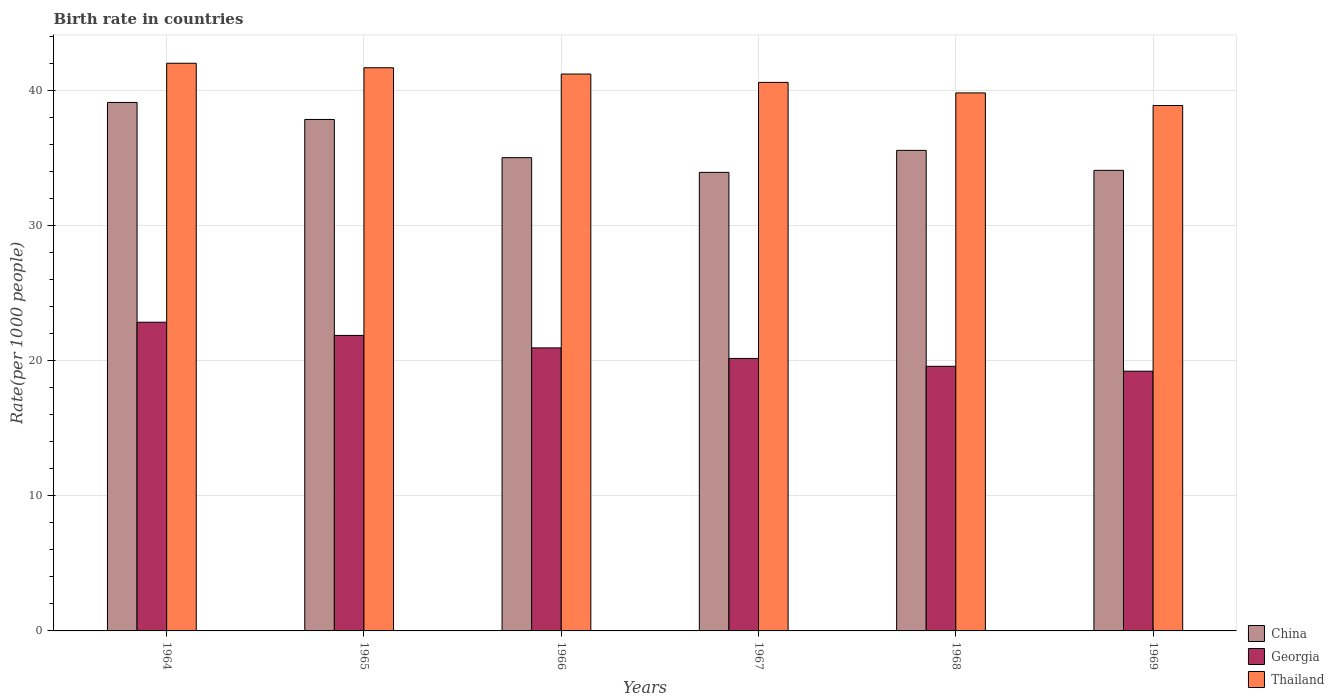How many groups of bars are there?
Your response must be concise. 6. Are the number of bars per tick equal to the number of legend labels?
Give a very brief answer. Yes. Are the number of bars on each tick of the X-axis equal?
Keep it short and to the point. Yes. How many bars are there on the 1st tick from the right?
Ensure brevity in your answer.  3. What is the label of the 2nd group of bars from the left?
Your answer should be compact. 1965. What is the birth rate in China in 1968?
Your answer should be very brief. 35.59. Across all years, what is the maximum birth rate in Georgia?
Ensure brevity in your answer.  22.86. Across all years, what is the minimum birth rate in Thailand?
Offer a terse response. 38.91. In which year was the birth rate in Thailand maximum?
Your answer should be very brief. 1964. In which year was the birth rate in China minimum?
Your answer should be very brief. 1967. What is the total birth rate in Georgia in the graph?
Provide a short and direct response. 124.72. What is the difference between the birth rate in Georgia in 1964 and that in 1968?
Offer a terse response. 3.26. What is the difference between the birth rate in Thailand in 1966 and the birth rate in Georgia in 1967?
Offer a very short reply. 21.06. What is the average birth rate in Georgia per year?
Offer a terse response. 20.79. In the year 1969, what is the difference between the birth rate in Thailand and birth rate in Georgia?
Your answer should be very brief. 19.68. What is the ratio of the birth rate in Thailand in 1965 to that in 1966?
Provide a short and direct response. 1.01. Is the birth rate in Thailand in 1965 less than that in 1969?
Offer a terse response. No. Is the difference between the birth rate in Thailand in 1966 and 1968 greater than the difference between the birth rate in Georgia in 1966 and 1968?
Your answer should be compact. Yes. What is the difference between the highest and the second highest birth rate in Thailand?
Ensure brevity in your answer.  0.33. What is the difference between the highest and the lowest birth rate in Thailand?
Offer a very short reply. 3.13. In how many years, is the birth rate in China greater than the average birth rate in China taken over all years?
Ensure brevity in your answer.  2. What does the 3rd bar from the left in 1964 represents?
Your response must be concise. Thailand. What does the 3rd bar from the right in 1967 represents?
Give a very brief answer. China. Is it the case that in every year, the sum of the birth rate in China and birth rate in Thailand is greater than the birth rate in Georgia?
Provide a succinct answer. Yes. How many bars are there?
Keep it short and to the point. 18. Are all the bars in the graph horizontal?
Offer a very short reply. No. How many years are there in the graph?
Ensure brevity in your answer.  6. What is the difference between two consecutive major ticks on the Y-axis?
Make the answer very short. 10. Are the values on the major ticks of Y-axis written in scientific E-notation?
Make the answer very short. No. Does the graph contain grids?
Keep it short and to the point. Yes. How many legend labels are there?
Ensure brevity in your answer.  3. What is the title of the graph?
Provide a succinct answer. Birth rate in countries. What is the label or title of the Y-axis?
Provide a succinct answer. Rate(per 1000 people). What is the Rate(per 1000 people) in China in 1964?
Your answer should be very brief. 39.14. What is the Rate(per 1000 people) in Georgia in 1964?
Provide a succinct answer. 22.86. What is the Rate(per 1000 people) in Thailand in 1964?
Your answer should be compact. 42.04. What is the Rate(per 1000 people) in China in 1965?
Keep it short and to the point. 37.88. What is the Rate(per 1000 people) in Georgia in 1965?
Your answer should be very brief. 21.89. What is the Rate(per 1000 people) of Thailand in 1965?
Your answer should be very brief. 41.71. What is the Rate(per 1000 people) of China in 1966?
Your response must be concise. 35.05. What is the Rate(per 1000 people) of Georgia in 1966?
Ensure brevity in your answer.  20.96. What is the Rate(per 1000 people) of Thailand in 1966?
Offer a very short reply. 41.24. What is the Rate(per 1000 people) in China in 1967?
Provide a succinct answer. 33.96. What is the Rate(per 1000 people) in Georgia in 1967?
Give a very brief answer. 20.18. What is the Rate(per 1000 people) in Thailand in 1967?
Offer a very short reply. 40.62. What is the Rate(per 1000 people) in China in 1968?
Ensure brevity in your answer.  35.59. What is the Rate(per 1000 people) of Georgia in 1968?
Offer a very short reply. 19.6. What is the Rate(per 1000 people) in Thailand in 1968?
Your answer should be compact. 39.85. What is the Rate(per 1000 people) of China in 1969?
Your answer should be very brief. 34.11. What is the Rate(per 1000 people) in Georgia in 1969?
Your answer should be compact. 19.24. What is the Rate(per 1000 people) in Thailand in 1969?
Your answer should be very brief. 38.91. Across all years, what is the maximum Rate(per 1000 people) of China?
Provide a succinct answer. 39.14. Across all years, what is the maximum Rate(per 1000 people) of Georgia?
Give a very brief answer. 22.86. Across all years, what is the maximum Rate(per 1000 people) of Thailand?
Your response must be concise. 42.04. Across all years, what is the minimum Rate(per 1000 people) of China?
Keep it short and to the point. 33.96. Across all years, what is the minimum Rate(per 1000 people) of Georgia?
Offer a terse response. 19.24. Across all years, what is the minimum Rate(per 1000 people) of Thailand?
Give a very brief answer. 38.91. What is the total Rate(per 1000 people) in China in the graph?
Ensure brevity in your answer.  215.73. What is the total Rate(per 1000 people) of Georgia in the graph?
Offer a very short reply. 124.72. What is the total Rate(per 1000 people) in Thailand in the graph?
Provide a short and direct response. 244.38. What is the difference between the Rate(per 1000 people) of China in 1964 and that in 1965?
Provide a short and direct response. 1.26. What is the difference between the Rate(per 1000 people) in Thailand in 1964 and that in 1965?
Your response must be concise. 0.33. What is the difference between the Rate(per 1000 people) of China in 1964 and that in 1966?
Offer a very short reply. 4.09. What is the difference between the Rate(per 1000 people) of Thailand in 1964 and that in 1966?
Provide a succinct answer. 0.8. What is the difference between the Rate(per 1000 people) in China in 1964 and that in 1967?
Ensure brevity in your answer.  5.18. What is the difference between the Rate(per 1000 people) in Georgia in 1964 and that in 1967?
Give a very brief answer. 2.68. What is the difference between the Rate(per 1000 people) in Thailand in 1964 and that in 1967?
Offer a terse response. 1.42. What is the difference between the Rate(per 1000 people) in China in 1964 and that in 1968?
Your response must be concise. 3.55. What is the difference between the Rate(per 1000 people) of Georgia in 1964 and that in 1968?
Provide a short and direct response. 3.26. What is the difference between the Rate(per 1000 people) of Thailand in 1964 and that in 1968?
Ensure brevity in your answer.  2.2. What is the difference between the Rate(per 1000 people) in China in 1964 and that in 1969?
Provide a short and direct response. 5.03. What is the difference between the Rate(per 1000 people) in Georgia in 1964 and that in 1969?
Make the answer very short. 3.63. What is the difference between the Rate(per 1000 people) of Thailand in 1964 and that in 1969?
Make the answer very short. 3.13. What is the difference between the Rate(per 1000 people) of China in 1965 and that in 1966?
Your answer should be very brief. 2.83. What is the difference between the Rate(per 1000 people) of Georgia in 1965 and that in 1966?
Offer a very short reply. 0.92. What is the difference between the Rate(per 1000 people) in Thailand in 1965 and that in 1966?
Keep it short and to the point. 0.47. What is the difference between the Rate(per 1000 people) of China in 1965 and that in 1967?
Offer a very short reply. 3.92. What is the difference between the Rate(per 1000 people) in Georgia in 1965 and that in 1967?
Keep it short and to the point. 1.71. What is the difference between the Rate(per 1000 people) of Thailand in 1965 and that in 1967?
Keep it short and to the point. 1.08. What is the difference between the Rate(per 1000 people) of China in 1965 and that in 1968?
Your response must be concise. 2.29. What is the difference between the Rate(per 1000 people) in Georgia in 1965 and that in 1968?
Give a very brief answer. 2.29. What is the difference between the Rate(per 1000 people) in Thailand in 1965 and that in 1968?
Make the answer very short. 1.86. What is the difference between the Rate(per 1000 people) in China in 1965 and that in 1969?
Your answer should be very brief. 3.77. What is the difference between the Rate(per 1000 people) in Georgia in 1965 and that in 1969?
Your answer should be very brief. 2.65. What is the difference between the Rate(per 1000 people) in Thailand in 1965 and that in 1969?
Keep it short and to the point. 2.8. What is the difference between the Rate(per 1000 people) in China in 1966 and that in 1967?
Give a very brief answer. 1.09. What is the difference between the Rate(per 1000 people) of Georgia in 1966 and that in 1967?
Offer a terse response. 0.78. What is the difference between the Rate(per 1000 people) in Thailand in 1966 and that in 1967?
Ensure brevity in your answer.  0.62. What is the difference between the Rate(per 1000 people) of China in 1966 and that in 1968?
Ensure brevity in your answer.  -0.54. What is the difference between the Rate(per 1000 people) of Georgia in 1966 and that in 1968?
Keep it short and to the point. 1.36. What is the difference between the Rate(per 1000 people) of Thailand in 1966 and that in 1968?
Keep it short and to the point. 1.4. What is the difference between the Rate(per 1000 people) of China in 1966 and that in 1969?
Keep it short and to the point. 0.94. What is the difference between the Rate(per 1000 people) of Georgia in 1966 and that in 1969?
Give a very brief answer. 1.73. What is the difference between the Rate(per 1000 people) in Thailand in 1966 and that in 1969?
Your answer should be very brief. 2.33. What is the difference between the Rate(per 1000 people) of China in 1967 and that in 1968?
Provide a short and direct response. -1.63. What is the difference between the Rate(per 1000 people) of Georgia in 1967 and that in 1968?
Your answer should be very brief. 0.58. What is the difference between the Rate(per 1000 people) in Thailand in 1967 and that in 1968?
Make the answer very short. 0.78. What is the difference between the Rate(per 1000 people) in China in 1967 and that in 1969?
Ensure brevity in your answer.  -0.15. What is the difference between the Rate(per 1000 people) in Georgia in 1967 and that in 1969?
Keep it short and to the point. 0.94. What is the difference between the Rate(per 1000 people) of Thailand in 1967 and that in 1969?
Your response must be concise. 1.71. What is the difference between the Rate(per 1000 people) of China in 1968 and that in 1969?
Your answer should be compact. 1.48. What is the difference between the Rate(per 1000 people) in Georgia in 1968 and that in 1969?
Ensure brevity in your answer.  0.36. What is the difference between the Rate(per 1000 people) in Thailand in 1968 and that in 1969?
Offer a very short reply. 0.93. What is the difference between the Rate(per 1000 people) in China in 1964 and the Rate(per 1000 people) in Georgia in 1965?
Your answer should be compact. 17.25. What is the difference between the Rate(per 1000 people) of China in 1964 and the Rate(per 1000 people) of Thailand in 1965?
Offer a terse response. -2.57. What is the difference between the Rate(per 1000 people) of Georgia in 1964 and the Rate(per 1000 people) of Thailand in 1965?
Offer a terse response. -18.85. What is the difference between the Rate(per 1000 people) of China in 1964 and the Rate(per 1000 people) of Georgia in 1966?
Offer a very short reply. 18.18. What is the difference between the Rate(per 1000 people) in China in 1964 and the Rate(per 1000 people) in Thailand in 1966?
Your response must be concise. -2.1. What is the difference between the Rate(per 1000 people) in Georgia in 1964 and the Rate(per 1000 people) in Thailand in 1966?
Your response must be concise. -18.38. What is the difference between the Rate(per 1000 people) of China in 1964 and the Rate(per 1000 people) of Georgia in 1967?
Give a very brief answer. 18.96. What is the difference between the Rate(per 1000 people) of China in 1964 and the Rate(per 1000 people) of Thailand in 1967?
Your response must be concise. -1.49. What is the difference between the Rate(per 1000 people) in Georgia in 1964 and the Rate(per 1000 people) in Thailand in 1967?
Provide a short and direct response. -17.76. What is the difference between the Rate(per 1000 people) of China in 1964 and the Rate(per 1000 people) of Georgia in 1968?
Provide a short and direct response. 19.54. What is the difference between the Rate(per 1000 people) of China in 1964 and the Rate(per 1000 people) of Thailand in 1968?
Offer a terse response. -0.71. What is the difference between the Rate(per 1000 people) of Georgia in 1964 and the Rate(per 1000 people) of Thailand in 1968?
Your response must be concise. -16.98. What is the difference between the Rate(per 1000 people) of China in 1964 and the Rate(per 1000 people) of Georgia in 1969?
Offer a terse response. 19.9. What is the difference between the Rate(per 1000 people) of China in 1964 and the Rate(per 1000 people) of Thailand in 1969?
Ensure brevity in your answer.  0.23. What is the difference between the Rate(per 1000 people) in Georgia in 1964 and the Rate(per 1000 people) in Thailand in 1969?
Keep it short and to the point. -16.05. What is the difference between the Rate(per 1000 people) of China in 1965 and the Rate(per 1000 people) of Georgia in 1966?
Your answer should be compact. 16.92. What is the difference between the Rate(per 1000 people) in China in 1965 and the Rate(per 1000 people) in Thailand in 1966?
Your answer should be compact. -3.36. What is the difference between the Rate(per 1000 people) of Georgia in 1965 and the Rate(per 1000 people) of Thailand in 1966?
Keep it short and to the point. -19.36. What is the difference between the Rate(per 1000 people) in China in 1965 and the Rate(per 1000 people) in Thailand in 1967?
Make the answer very short. -2.75. What is the difference between the Rate(per 1000 people) of Georgia in 1965 and the Rate(per 1000 people) of Thailand in 1967?
Give a very brief answer. -18.74. What is the difference between the Rate(per 1000 people) in China in 1965 and the Rate(per 1000 people) in Georgia in 1968?
Provide a short and direct response. 18.28. What is the difference between the Rate(per 1000 people) of China in 1965 and the Rate(per 1000 people) of Thailand in 1968?
Offer a very short reply. -1.97. What is the difference between the Rate(per 1000 people) in Georgia in 1965 and the Rate(per 1000 people) in Thailand in 1968?
Give a very brief answer. -17.96. What is the difference between the Rate(per 1000 people) of China in 1965 and the Rate(per 1000 people) of Georgia in 1969?
Your response must be concise. 18.64. What is the difference between the Rate(per 1000 people) of China in 1965 and the Rate(per 1000 people) of Thailand in 1969?
Your answer should be very brief. -1.03. What is the difference between the Rate(per 1000 people) in Georgia in 1965 and the Rate(per 1000 people) in Thailand in 1969?
Your response must be concise. -17.03. What is the difference between the Rate(per 1000 people) of China in 1966 and the Rate(per 1000 people) of Georgia in 1967?
Your answer should be compact. 14.87. What is the difference between the Rate(per 1000 people) of China in 1966 and the Rate(per 1000 people) of Thailand in 1967?
Make the answer very short. -5.58. What is the difference between the Rate(per 1000 people) of Georgia in 1966 and the Rate(per 1000 people) of Thailand in 1967?
Ensure brevity in your answer.  -19.66. What is the difference between the Rate(per 1000 people) in China in 1966 and the Rate(per 1000 people) in Georgia in 1968?
Ensure brevity in your answer.  15.45. What is the difference between the Rate(per 1000 people) in China in 1966 and the Rate(per 1000 people) in Thailand in 1968?
Your answer should be compact. -4.8. What is the difference between the Rate(per 1000 people) of Georgia in 1966 and the Rate(per 1000 people) of Thailand in 1968?
Keep it short and to the point. -18.88. What is the difference between the Rate(per 1000 people) in China in 1966 and the Rate(per 1000 people) in Georgia in 1969?
Provide a succinct answer. 15.81. What is the difference between the Rate(per 1000 people) in China in 1966 and the Rate(per 1000 people) in Thailand in 1969?
Give a very brief answer. -3.86. What is the difference between the Rate(per 1000 people) of Georgia in 1966 and the Rate(per 1000 people) of Thailand in 1969?
Your response must be concise. -17.95. What is the difference between the Rate(per 1000 people) in China in 1967 and the Rate(per 1000 people) in Georgia in 1968?
Offer a terse response. 14.36. What is the difference between the Rate(per 1000 people) of China in 1967 and the Rate(per 1000 people) of Thailand in 1968?
Offer a terse response. -5.89. What is the difference between the Rate(per 1000 people) in Georgia in 1967 and the Rate(per 1000 people) in Thailand in 1968?
Provide a succinct answer. -19.67. What is the difference between the Rate(per 1000 people) in China in 1967 and the Rate(per 1000 people) in Georgia in 1969?
Your answer should be very brief. 14.72. What is the difference between the Rate(per 1000 people) of China in 1967 and the Rate(per 1000 people) of Thailand in 1969?
Ensure brevity in your answer.  -4.95. What is the difference between the Rate(per 1000 people) in Georgia in 1967 and the Rate(per 1000 people) in Thailand in 1969?
Your answer should be very brief. -18.73. What is the difference between the Rate(per 1000 people) of China in 1968 and the Rate(per 1000 people) of Georgia in 1969?
Your response must be concise. 16.35. What is the difference between the Rate(per 1000 people) of China in 1968 and the Rate(per 1000 people) of Thailand in 1969?
Give a very brief answer. -3.32. What is the difference between the Rate(per 1000 people) in Georgia in 1968 and the Rate(per 1000 people) in Thailand in 1969?
Your answer should be very brief. -19.32. What is the average Rate(per 1000 people) in China per year?
Provide a succinct answer. 35.95. What is the average Rate(per 1000 people) of Georgia per year?
Make the answer very short. 20.79. What is the average Rate(per 1000 people) of Thailand per year?
Your response must be concise. 40.73. In the year 1964, what is the difference between the Rate(per 1000 people) of China and Rate(per 1000 people) of Georgia?
Ensure brevity in your answer.  16.28. In the year 1964, what is the difference between the Rate(per 1000 people) in China and Rate(per 1000 people) in Thailand?
Make the answer very short. -2.9. In the year 1964, what is the difference between the Rate(per 1000 people) of Georgia and Rate(per 1000 people) of Thailand?
Give a very brief answer. -19.18. In the year 1965, what is the difference between the Rate(per 1000 people) in China and Rate(per 1000 people) in Georgia?
Give a very brief answer. 15.99. In the year 1965, what is the difference between the Rate(per 1000 people) of China and Rate(per 1000 people) of Thailand?
Provide a succinct answer. -3.83. In the year 1965, what is the difference between the Rate(per 1000 people) in Georgia and Rate(per 1000 people) in Thailand?
Make the answer very short. -19.82. In the year 1966, what is the difference between the Rate(per 1000 people) of China and Rate(per 1000 people) of Georgia?
Your answer should be compact. 14.09. In the year 1966, what is the difference between the Rate(per 1000 people) in China and Rate(per 1000 people) in Thailand?
Provide a succinct answer. -6.19. In the year 1966, what is the difference between the Rate(per 1000 people) in Georgia and Rate(per 1000 people) in Thailand?
Provide a succinct answer. -20.28. In the year 1967, what is the difference between the Rate(per 1000 people) of China and Rate(per 1000 people) of Georgia?
Ensure brevity in your answer.  13.78. In the year 1967, what is the difference between the Rate(per 1000 people) of China and Rate(per 1000 people) of Thailand?
Provide a succinct answer. -6.67. In the year 1967, what is the difference between the Rate(per 1000 people) of Georgia and Rate(per 1000 people) of Thailand?
Make the answer very short. -20.45. In the year 1968, what is the difference between the Rate(per 1000 people) in China and Rate(per 1000 people) in Georgia?
Your response must be concise. 15.99. In the year 1968, what is the difference between the Rate(per 1000 people) of China and Rate(per 1000 people) of Thailand?
Give a very brief answer. -4.26. In the year 1968, what is the difference between the Rate(per 1000 people) of Georgia and Rate(per 1000 people) of Thailand?
Offer a very short reply. -20.25. In the year 1969, what is the difference between the Rate(per 1000 people) in China and Rate(per 1000 people) in Georgia?
Provide a succinct answer. 14.87. In the year 1969, what is the difference between the Rate(per 1000 people) in China and Rate(per 1000 people) in Thailand?
Provide a succinct answer. -4.8. In the year 1969, what is the difference between the Rate(per 1000 people) in Georgia and Rate(per 1000 people) in Thailand?
Give a very brief answer. -19.68. What is the ratio of the Rate(per 1000 people) of Georgia in 1964 to that in 1965?
Provide a short and direct response. 1.04. What is the ratio of the Rate(per 1000 people) in Thailand in 1964 to that in 1965?
Make the answer very short. 1.01. What is the ratio of the Rate(per 1000 people) of China in 1964 to that in 1966?
Offer a terse response. 1.12. What is the ratio of the Rate(per 1000 people) of Georgia in 1964 to that in 1966?
Offer a terse response. 1.09. What is the ratio of the Rate(per 1000 people) of Thailand in 1964 to that in 1966?
Provide a succinct answer. 1.02. What is the ratio of the Rate(per 1000 people) of China in 1964 to that in 1967?
Keep it short and to the point. 1.15. What is the ratio of the Rate(per 1000 people) in Georgia in 1964 to that in 1967?
Give a very brief answer. 1.13. What is the ratio of the Rate(per 1000 people) in Thailand in 1964 to that in 1967?
Keep it short and to the point. 1.03. What is the ratio of the Rate(per 1000 people) in China in 1964 to that in 1968?
Offer a very short reply. 1.1. What is the ratio of the Rate(per 1000 people) of Georgia in 1964 to that in 1968?
Your response must be concise. 1.17. What is the ratio of the Rate(per 1000 people) of Thailand in 1964 to that in 1968?
Your answer should be compact. 1.06. What is the ratio of the Rate(per 1000 people) in China in 1964 to that in 1969?
Provide a short and direct response. 1.15. What is the ratio of the Rate(per 1000 people) of Georgia in 1964 to that in 1969?
Provide a short and direct response. 1.19. What is the ratio of the Rate(per 1000 people) in Thailand in 1964 to that in 1969?
Provide a short and direct response. 1.08. What is the ratio of the Rate(per 1000 people) of China in 1965 to that in 1966?
Ensure brevity in your answer.  1.08. What is the ratio of the Rate(per 1000 people) in Georgia in 1965 to that in 1966?
Keep it short and to the point. 1.04. What is the ratio of the Rate(per 1000 people) of Thailand in 1965 to that in 1966?
Your response must be concise. 1.01. What is the ratio of the Rate(per 1000 people) of China in 1965 to that in 1967?
Provide a succinct answer. 1.12. What is the ratio of the Rate(per 1000 people) in Georgia in 1965 to that in 1967?
Provide a short and direct response. 1.08. What is the ratio of the Rate(per 1000 people) of Thailand in 1965 to that in 1967?
Keep it short and to the point. 1.03. What is the ratio of the Rate(per 1000 people) of China in 1965 to that in 1968?
Offer a very short reply. 1.06. What is the ratio of the Rate(per 1000 people) of Georgia in 1965 to that in 1968?
Your response must be concise. 1.12. What is the ratio of the Rate(per 1000 people) of Thailand in 1965 to that in 1968?
Offer a very short reply. 1.05. What is the ratio of the Rate(per 1000 people) in China in 1965 to that in 1969?
Give a very brief answer. 1.11. What is the ratio of the Rate(per 1000 people) in Georgia in 1965 to that in 1969?
Provide a short and direct response. 1.14. What is the ratio of the Rate(per 1000 people) of Thailand in 1965 to that in 1969?
Your answer should be compact. 1.07. What is the ratio of the Rate(per 1000 people) in China in 1966 to that in 1967?
Ensure brevity in your answer.  1.03. What is the ratio of the Rate(per 1000 people) in Georgia in 1966 to that in 1967?
Your answer should be compact. 1.04. What is the ratio of the Rate(per 1000 people) in Thailand in 1966 to that in 1967?
Ensure brevity in your answer.  1.02. What is the ratio of the Rate(per 1000 people) in Georgia in 1966 to that in 1968?
Ensure brevity in your answer.  1.07. What is the ratio of the Rate(per 1000 people) of Thailand in 1966 to that in 1968?
Offer a very short reply. 1.04. What is the ratio of the Rate(per 1000 people) in China in 1966 to that in 1969?
Offer a terse response. 1.03. What is the ratio of the Rate(per 1000 people) of Georgia in 1966 to that in 1969?
Your answer should be compact. 1.09. What is the ratio of the Rate(per 1000 people) in Thailand in 1966 to that in 1969?
Your answer should be very brief. 1.06. What is the ratio of the Rate(per 1000 people) in China in 1967 to that in 1968?
Offer a terse response. 0.95. What is the ratio of the Rate(per 1000 people) in Georgia in 1967 to that in 1968?
Ensure brevity in your answer.  1.03. What is the ratio of the Rate(per 1000 people) in Thailand in 1967 to that in 1968?
Provide a succinct answer. 1.02. What is the ratio of the Rate(per 1000 people) in China in 1967 to that in 1969?
Your answer should be compact. 1. What is the ratio of the Rate(per 1000 people) of Georgia in 1967 to that in 1969?
Offer a terse response. 1.05. What is the ratio of the Rate(per 1000 people) in Thailand in 1967 to that in 1969?
Offer a very short reply. 1.04. What is the ratio of the Rate(per 1000 people) of China in 1968 to that in 1969?
Provide a short and direct response. 1.04. What is the ratio of the Rate(per 1000 people) in Georgia in 1968 to that in 1969?
Offer a very short reply. 1.02. What is the difference between the highest and the second highest Rate(per 1000 people) of China?
Provide a short and direct response. 1.26. What is the difference between the highest and the second highest Rate(per 1000 people) of Georgia?
Provide a succinct answer. 0.98. What is the difference between the highest and the second highest Rate(per 1000 people) in Thailand?
Ensure brevity in your answer.  0.33. What is the difference between the highest and the lowest Rate(per 1000 people) of China?
Make the answer very short. 5.18. What is the difference between the highest and the lowest Rate(per 1000 people) in Georgia?
Provide a short and direct response. 3.63. What is the difference between the highest and the lowest Rate(per 1000 people) of Thailand?
Provide a succinct answer. 3.13. 